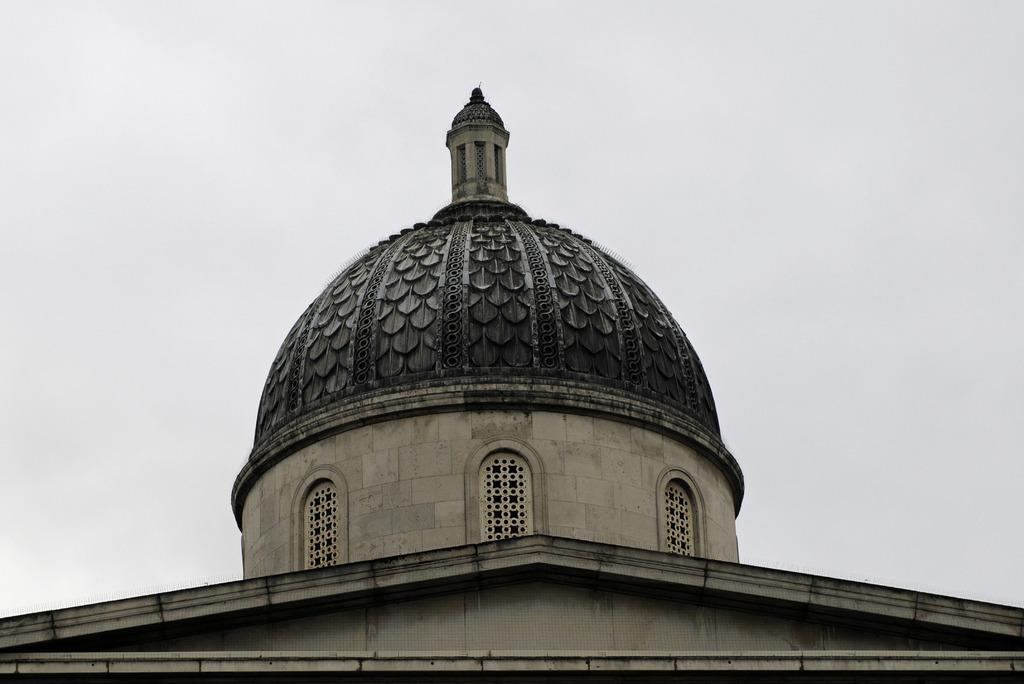What structure is present in the image? There is a building in the image. What architectural feature can be seen on the building? There are arches on the building. Can you find a note left by someone on the seashore in the image? There is no seashore or note present in the image; it features a building with arches. Is the building sinking into quicksand in the image? There is no quicksand present in the image, and the building is not sinking. 